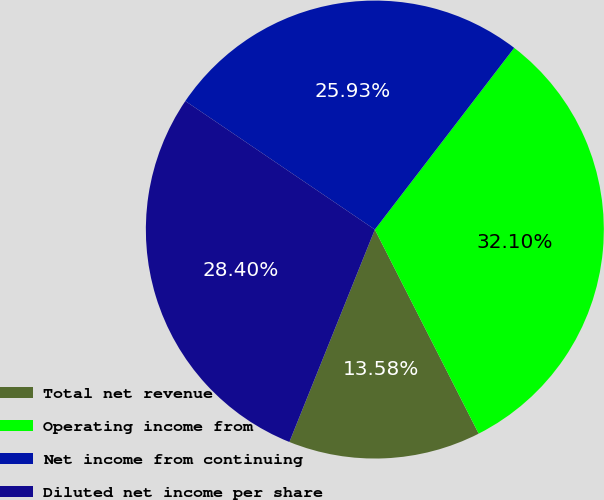<chart> <loc_0><loc_0><loc_500><loc_500><pie_chart><fcel>Total net revenue<fcel>Operating income from<fcel>Net income from continuing<fcel>Diluted net income per share<nl><fcel>13.58%<fcel>32.1%<fcel>25.93%<fcel>28.4%<nl></chart> 